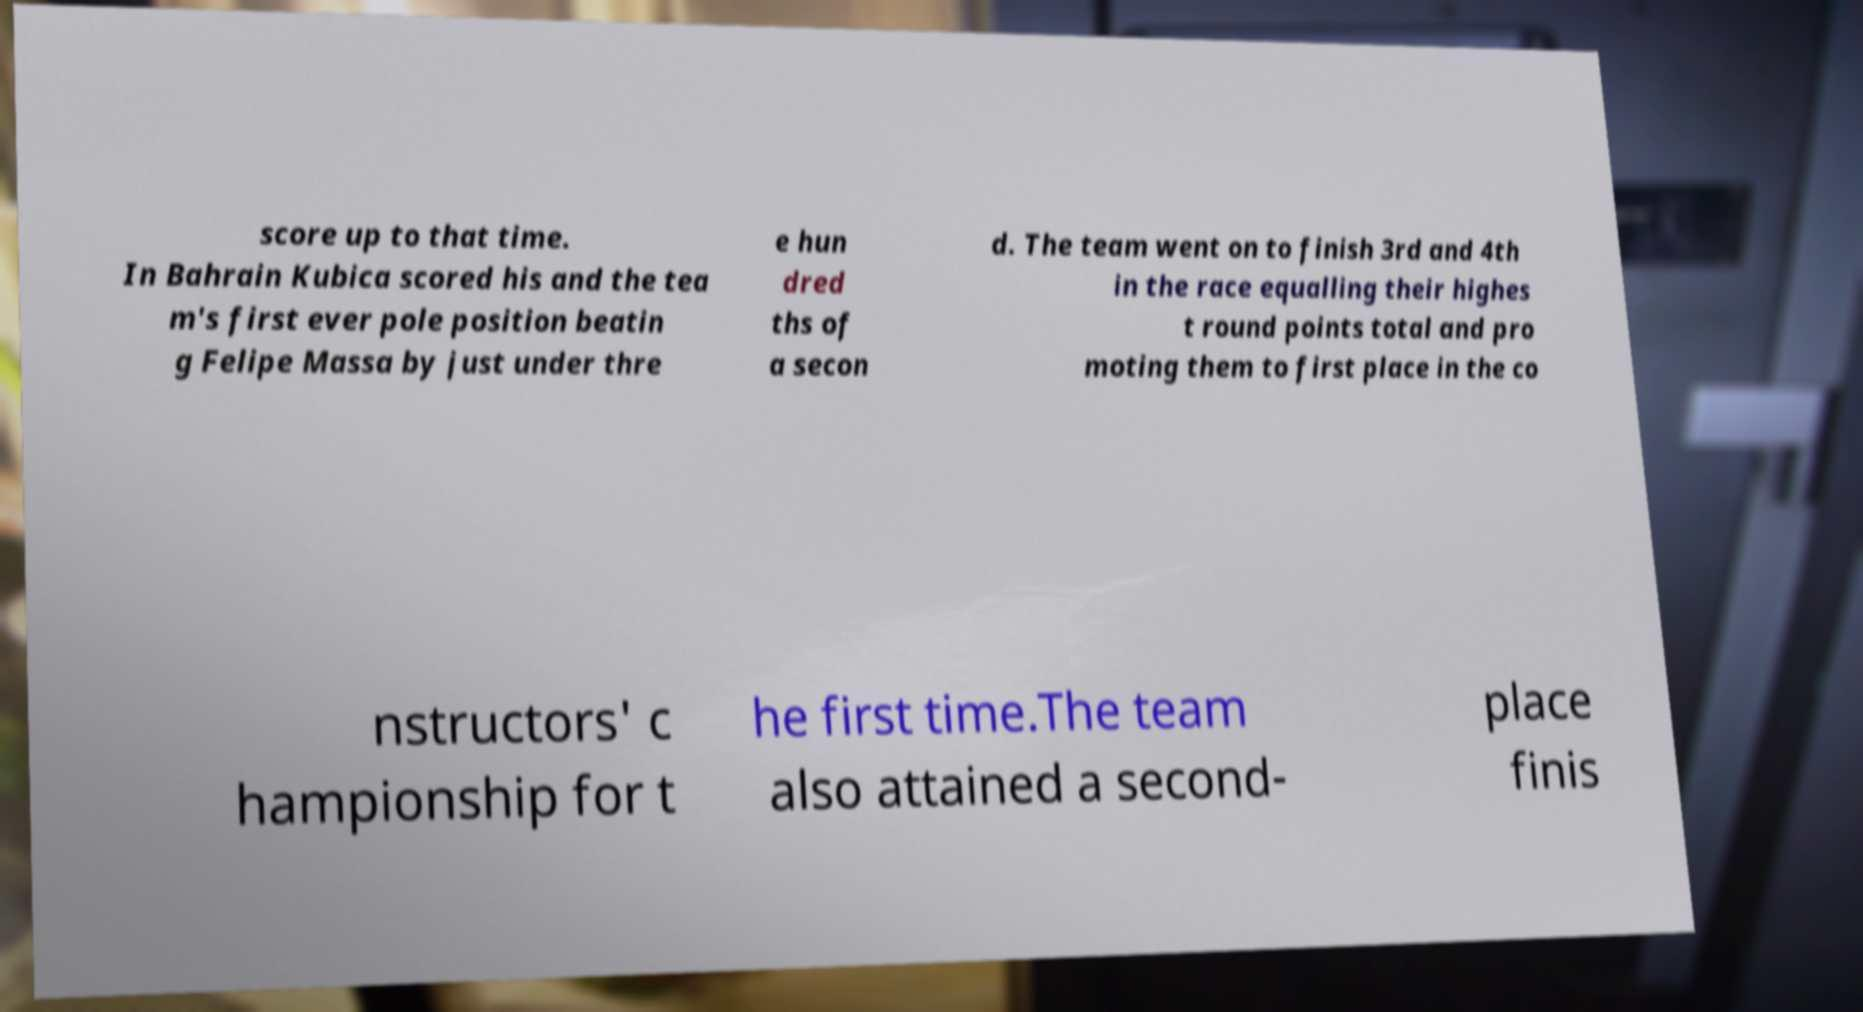Can you accurately transcribe the text from the provided image for me? score up to that time. In Bahrain Kubica scored his and the tea m's first ever pole position beatin g Felipe Massa by just under thre e hun dred ths of a secon d. The team went on to finish 3rd and 4th in the race equalling their highes t round points total and pro moting them to first place in the co nstructors' c hampionship for t he first time.The team also attained a second- place finis 